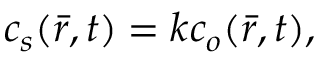Convert formula to latex. <formula><loc_0><loc_0><loc_500><loc_500>\begin{array} { r } { c _ { s } ( \bar { r } , t ) = k c _ { o } ( \bar { r } , t ) , } \end{array}</formula> 